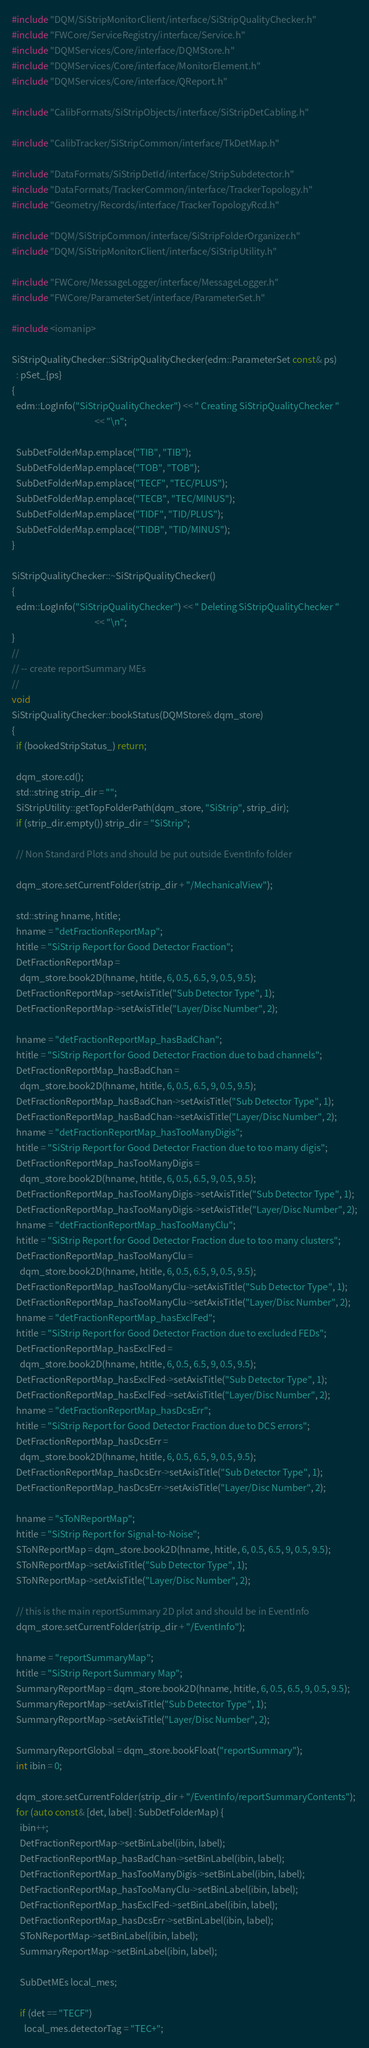<code> <loc_0><loc_0><loc_500><loc_500><_C++_>#include "DQM/SiStripMonitorClient/interface/SiStripQualityChecker.h"
#include "FWCore/ServiceRegistry/interface/Service.h"
#include "DQMServices/Core/interface/DQMStore.h"
#include "DQMServices/Core/interface/MonitorElement.h"
#include "DQMServices/Core/interface/QReport.h"

#include "CalibFormats/SiStripObjects/interface/SiStripDetCabling.h"

#include "CalibTracker/SiStripCommon/interface/TkDetMap.h"

#include "DataFormats/SiStripDetId/interface/StripSubdetector.h"
#include "DataFormats/TrackerCommon/interface/TrackerTopology.h"
#include "Geometry/Records/interface/TrackerTopologyRcd.h"

#include "DQM/SiStripCommon/interface/SiStripFolderOrganizer.h"
#include "DQM/SiStripMonitorClient/interface/SiStripUtility.h"

#include "FWCore/MessageLogger/interface/MessageLogger.h"
#include "FWCore/ParameterSet/interface/ParameterSet.h"

#include <iomanip>

SiStripQualityChecker::SiStripQualityChecker(edm::ParameterSet const& ps)
  : pSet_{ps}
{
  edm::LogInfo("SiStripQualityChecker") << " Creating SiStripQualityChecker "
                                        << "\n";

  SubDetFolderMap.emplace("TIB", "TIB");
  SubDetFolderMap.emplace("TOB", "TOB");
  SubDetFolderMap.emplace("TECF", "TEC/PLUS");
  SubDetFolderMap.emplace("TECB", "TEC/MINUS");
  SubDetFolderMap.emplace("TIDF", "TID/PLUS");
  SubDetFolderMap.emplace("TIDB", "TID/MINUS");
}

SiStripQualityChecker::~SiStripQualityChecker()
{
  edm::LogInfo("SiStripQualityChecker") << " Deleting SiStripQualityChecker "
                                        << "\n";
}
//
// -- create reportSummary MEs
//
void
SiStripQualityChecker::bookStatus(DQMStore& dqm_store)
{
  if (bookedStripStatus_) return;

  dqm_store.cd();
  std::string strip_dir = "";
  SiStripUtility::getTopFolderPath(dqm_store, "SiStrip", strip_dir);
  if (strip_dir.empty()) strip_dir = "SiStrip";

  // Non Standard Plots and should be put outside EventInfo folder

  dqm_store.setCurrentFolder(strip_dir + "/MechanicalView");

  std::string hname, htitle;
  hname = "detFractionReportMap";
  htitle = "SiStrip Report for Good Detector Fraction";
  DetFractionReportMap =
    dqm_store.book2D(hname, htitle, 6, 0.5, 6.5, 9, 0.5, 9.5);
  DetFractionReportMap->setAxisTitle("Sub Detector Type", 1);
  DetFractionReportMap->setAxisTitle("Layer/Disc Number", 2);

  hname = "detFractionReportMap_hasBadChan";
  htitle = "SiStrip Report for Good Detector Fraction due to bad channels";
  DetFractionReportMap_hasBadChan =
    dqm_store.book2D(hname, htitle, 6, 0.5, 6.5, 9, 0.5, 9.5);
  DetFractionReportMap_hasBadChan->setAxisTitle("Sub Detector Type", 1);
  DetFractionReportMap_hasBadChan->setAxisTitle("Layer/Disc Number", 2);
  hname = "detFractionReportMap_hasTooManyDigis";
  htitle = "SiStrip Report for Good Detector Fraction due to too many digis";
  DetFractionReportMap_hasTooManyDigis =
    dqm_store.book2D(hname, htitle, 6, 0.5, 6.5, 9, 0.5, 9.5);
  DetFractionReportMap_hasTooManyDigis->setAxisTitle("Sub Detector Type", 1);
  DetFractionReportMap_hasTooManyDigis->setAxisTitle("Layer/Disc Number", 2);
  hname = "detFractionReportMap_hasTooManyClu";
  htitle = "SiStrip Report for Good Detector Fraction due to too many clusters";
  DetFractionReportMap_hasTooManyClu =
    dqm_store.book2D(hname, htitle, 6, 0.5, 6.5, 9, 0.5, 9.5);
  DetFractionReportMap_hasTooManyClu->setAxisTitle("Sub Detector Type", 1);
  DetFractionReportMap_hasTooManyClu->setAxisTitle("Layer/Disc Number", 2);
  hname = "detFractionReportMap_hasExclFed";
  htitle = "SiStrip Report for Good Detector Fraction due to excluded FEDs";
  DetFractionReportMap_hasExclFed =
    dqm_store.book2D(hname, htitle, 6, 0.5, 6.5, 9, 0.5, 9.5);
  DetFractionReportMap_hasExclFed->setAxisTitle("Sub Detector Type", 1);
  DetFractionReportMap_hasExclFed->setAxisTitle("Layer/Disc Number", 2);
  hname = "detFractionReportMap_hasDcsErr";
  htitle = "SiStrip Report for Good Detector Fraction due to DCS errors";
  DetFractionReportMap_hasDcsErr =
    dqm_store.book2D(hname, htitle, 6, 0.5, 6.5, 9, 0.5, 9.5);
  DetFractionReportMap_hasDcsErr->setAxisTitle("Sub Detector Type", 1);
  DetFractionReportMap_hasDcsErr->setAxisTitle("Layer/Disc Number", 2);

  hname = "sToNReportMap";
  htitle = "SiStrip Report for Signal-to-Noise";
  SToNReportMap = dqm_store.book2D(hname, htitle, 6, 0.5, 6.5, 9, 0.5, 9.5);
  SToNReportMap->setAxisTitle("Sub Detector Type", 1);
  SToNReportMap->setAxisTitle("Layer/Disc Number", 2);

  // this is the main reportSummary 2D plot and should be in EventInfo
  dqm_store.setCurrentFolder(strip_dir + "/EventInfo");

  hname = "reportSummaryMap";
  htitle = "SiStrip Report Summary Map";
  SummaryReportMap = dqm_store.book2D(hname, htitle, 6, 0.5, 6.5, 9, 0.5, 9.5);
  SummaryReportMap->setAxisTitle("Sub Detector Type", 1);
  SummaryReportMap->setAxisTitle("Layer/Disc Number", 2);

  SummaryReportGlobal = dqm_store.bookFloat("reportSummary");
  int ibin = 0;

  dqm_store.setCurrentFolder(strip_dir + "/EventInfo/reportSummaryContents");
  for (auto const& [det, label] : SubDetFolderMap) {
    ibin++;
    DetFractionReportMap->setBinLabel(ibin, label);
    DetFractionReportMap_hasBadChan->setBinLabel(ibin, label);
    DetFractionReportMap_hasTooManyDigis->setBinLabel(ibin, label);
    DetFractionReportMap_hasTooManyClu->setBinLabel(ibin, label);
    DetFractionReportMap_hasExclFed->setBinLabel(ibin, label);
    DetFractionReportMap_hasDcsErr->setBinLabel(ibin, label);
    SToNReportMap->setBinLabel(ibin, label);
    SummaryReportMap->setBinLabel(ibin, label);

    SubDetMEs local_mes;

    if (det == "TECF")
      local_mes.detectorTag = "TEC+";</code> 